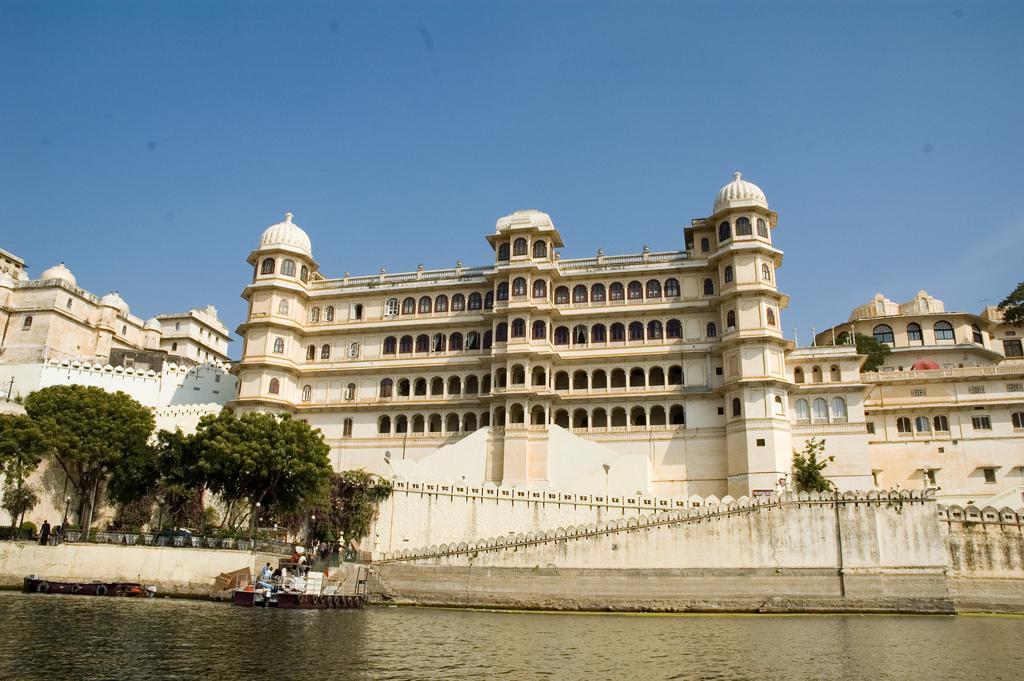Can you describe this image briefly? In this picture i can see the buildings and monuments. At the bottom there is a water. In the bottom left i can see some people were standing on the stairs and fencing. On the left i can see a man who is standing near to the trees. At the top there is a sky. 